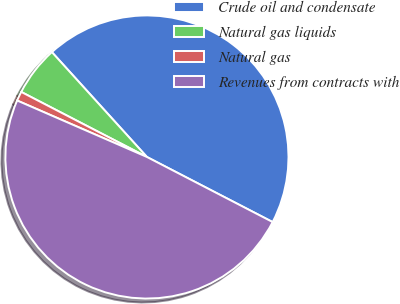Convert chart. <chart><loc_0><loc_0><loc_500><loc_500><pie_chart><fcel>Crude oil and condensate<fcel>Natural gas liquids<fcel>Natural gas<fcel>Revenues from contracts with<nl><fcel>44.32%<fcel>5.68%<fcel>1.07%<fcel>48.93%<nl></chart> 